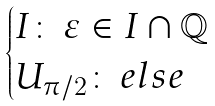<formula> <loc_0><loc_0><loc_500><loc_500>\begin{cases} I \colon \, \varepsilon \in I \cap \mathbb { Q } \\ U _ { \pi / 2 } \colon \, e l s e \end{cases}</formula> 